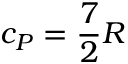<formula> <loc_0><loc_0><loc_500><loc_500>c _ { P } = { \frac { 7 } { 2 } } R</formula> 